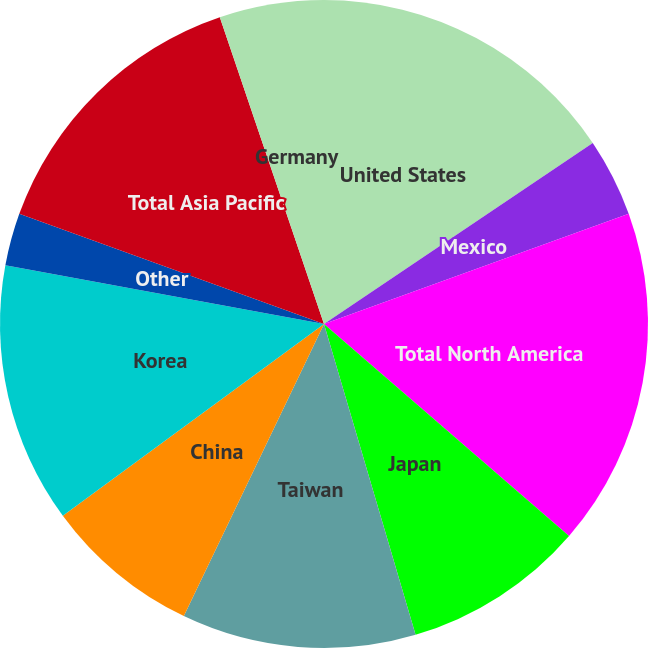<chart> <loc_0><loc_0><loc_500><loc_500><pie_chart><fcel>United States<fcel>Mexico<fcel>Total North America<fcel>Japan<fcel>Taiwan<fcel>China<fcel>Korea<fcel>Other<fcel>Total Asia Pacific<fcel>Germany<nl><fcel>15.57%<fcel>3.91%<fcel>16.87%<fcel>9.09%<fcel>11.68%<fcel>7.8%<fcel>12.98%<fcel>2.62%<fcel>14.27%<fcel>5.21%<nl></chart> 